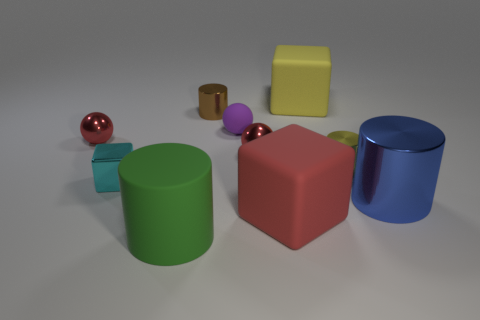What color is the tiny rubber object?
Offer a terse response. Purple. There is a matte ball that is the same size as the cyan shiny block; what color is it?
Offer a terse response. Purple. How many metallic objects are either tiny purple spheres or big red blocks?
Provide a short and direct response. 0. How many big matte cubes are both right of the red matte block and in front of the large yellow cube?
Ensure brevity in your answer.  0. What number of other objects are there of the same size as the green rubber thing?
Offer a very short reply. 3. There is a red thing that is in front of the tiny cyan shiny object; is it the same size as the red ball that is right of the big green rubber object?
Offer a very short reply. No. What number of objects are either tiny purple rubber things or small red metallic things left of the tiny cyan shiny cube?
Your answer should be very brief. 2. What size is the yellow object behind the yellow metallic thing?
Offer a very short reply. Large. Are there fewer purple rubber objects that are in front of the yellow shiny cylinder than red rubber blocks left of the large yellow matte thing?
Offer a very short reply. Yes. The thing that is both to the left of the small brown metallic cylinder and in front of the blue thing is made of what material?
Ensure brevity in your answer.  Rubber. 